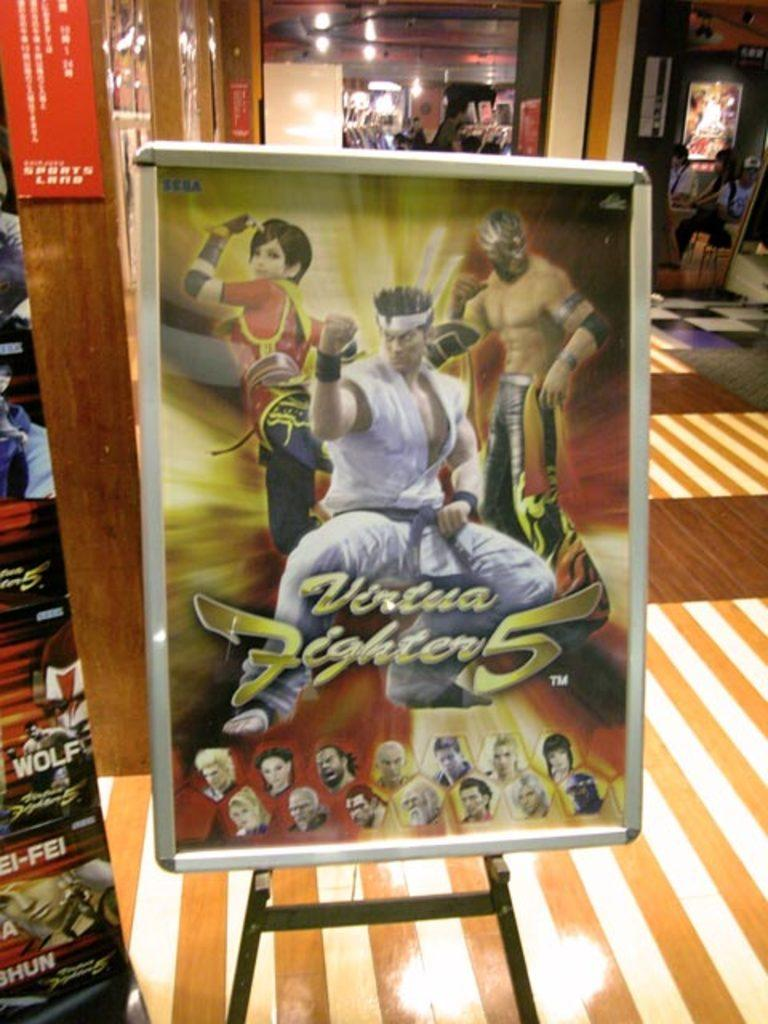What is the main object in the foreground of the image? There is a cartoon board in the image, and it is placed in the front. Who or what is behind the cartoon board? There are girls sitting behind the cartoon board. What can be seen on the wall above the girls? There are other posts on the wall above the girls. What type of business decision can be seen being made by the girls in the image? There is no indication of a business decision being made in the image; it features a cartoon board and girls sitting behind it. 